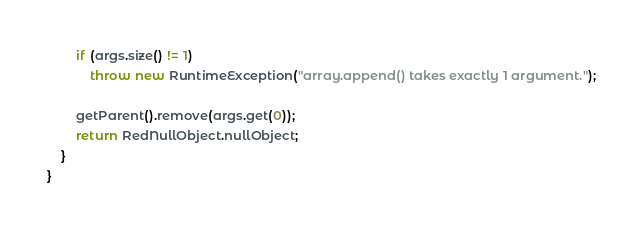Convert code to text. <code><loc_0><loc_0><loc_500><loc_500><_Java_>		if (args.size() != 1)
			throw new RuntimeException("array.append() takes exactly 1 argument.");

		getParent().remove(args.get(0));
		return RedNullObject.nullObject;
	}
}
</code> 